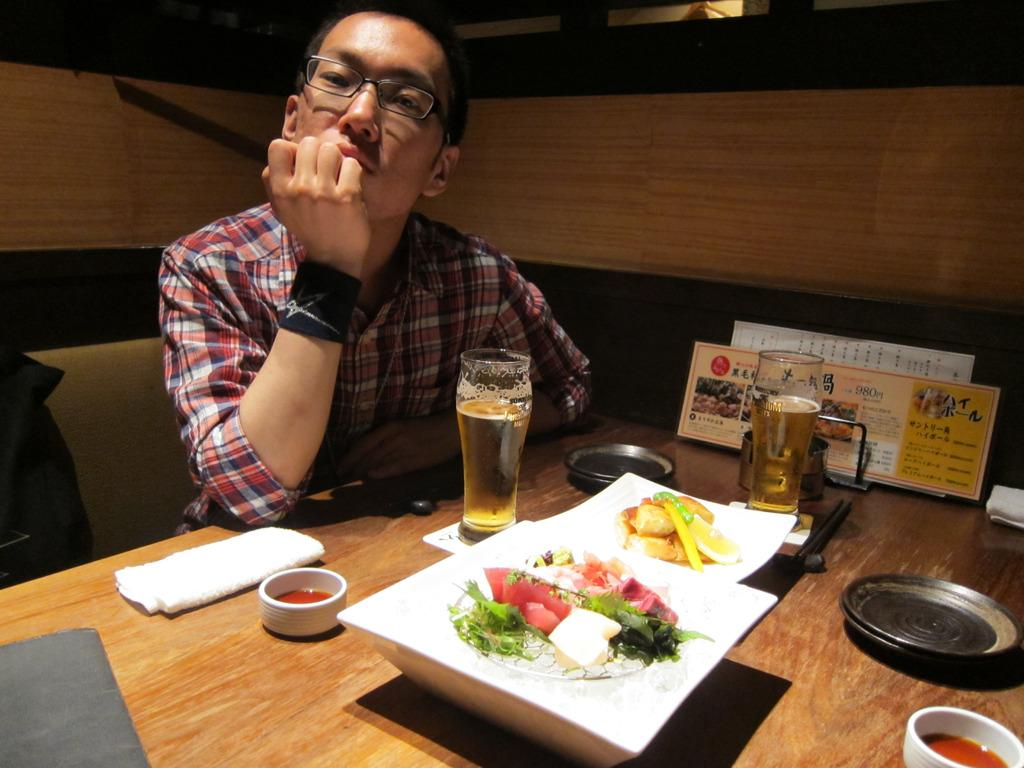What is the man in the image doing? The man is sitting in the image. What can be seen on the man's face? The man is wearing spectacles. What is on the table in the image? There are glasses, a plate, food, and other objects on the table. Where is the nest located in the image? There is no nest present in the image. What type of toothbrush is the man using in the image? There is no toothbrush visible in the image. 